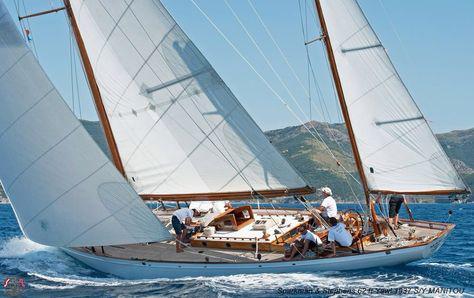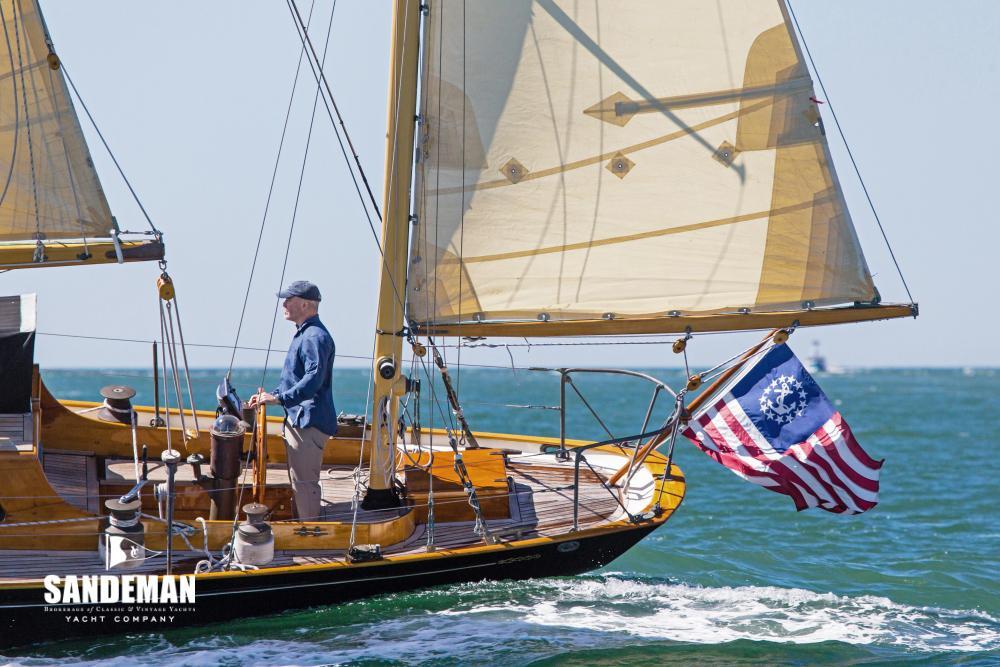The first image is the image on the left, the second image is the image on the right. Assess this claim about the two images: "Two sailboats on open water are headed in the same direction, but only one has a flag flying from the stern.". Correct or not? Answer yes or no. Yes. 